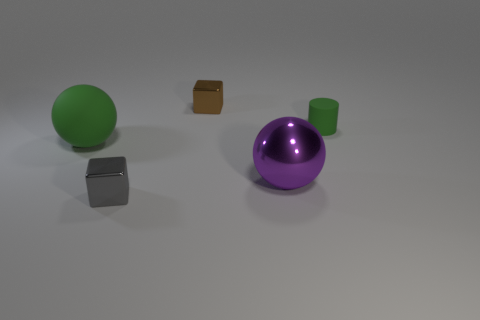The rubber sphere that is the same color as the matte cylinder is what size?
Keep it short and to the point. Large. What number of things are either metallic blocks or brown metallic cubes?
Your answer should be compact. 2. There is another metal block that is the same size as the gray cube; what is its color?
Offer a very short reply. Brown. Do the purple metallic object and the green thing that is in front of the tiny green cylinder have the same shape?
Offer a terse response. Yes. How many objects are either tiny gray shiny blocks on the left side of the brown cube or blocks that are behind the gray metal thing?
Offer a terse response. 2. There is a object that is the same color as the matte sphere; what shape is it?
Your response must be concise. Cylinder. There is a shiny object that is left of the brown object; what is its shape?
Ensure brevity in your answer.  Cube. Do the green matte thing left of the gray metallic object and the gray metal thing have the same shape?
Your response must be concise. No. What number of objects are metallic cubes behind the large purple thing or green spheres?
Your answer should be very brief. 2. What color is the other small metal thing that is the same shape as the small brown metallic thing?
Offer a terse response. Gray. 